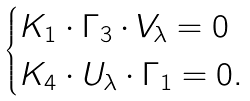<formula> <loc_0><loc_0><loc_500><loc_500>\begin{cases} K _ { 1 } \cdot \Gamma _ { 3 } \cdot V _ { \lambda } = 0 \\ K _ { 4 } \cdot U _ { \lambda } \cdot \Gamma _ { 1 } = 0 . \end{cases}</formula> 